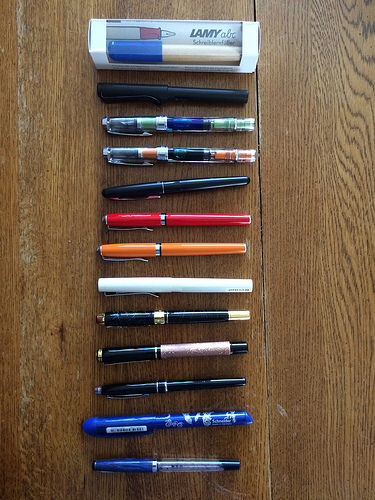<image>
Is the pen next to the pen? Yes. The pen is positioned adjacent to the pen, located nearby in the same general area. Where is the marker in relation to the box? Is it on the box? No. The marker is not positioned on the box. They may be near each other, but the marker is not supported by or resting on top of the box. Where is the table in relation to the pens? Is it on the pens? No. The table is not positioned on the pens. They may be near each other, but the table is not supported by or resting on top of the pens. 